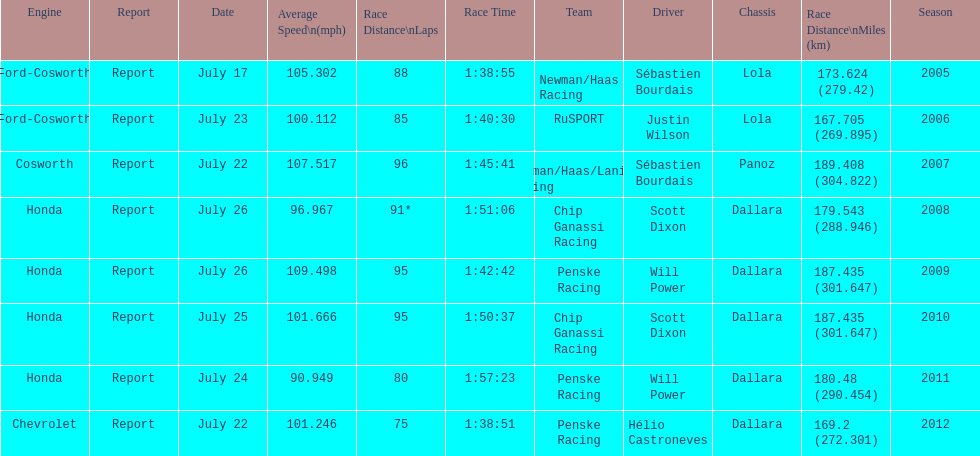What is the total number dallara chassis listed in the table? 5. 